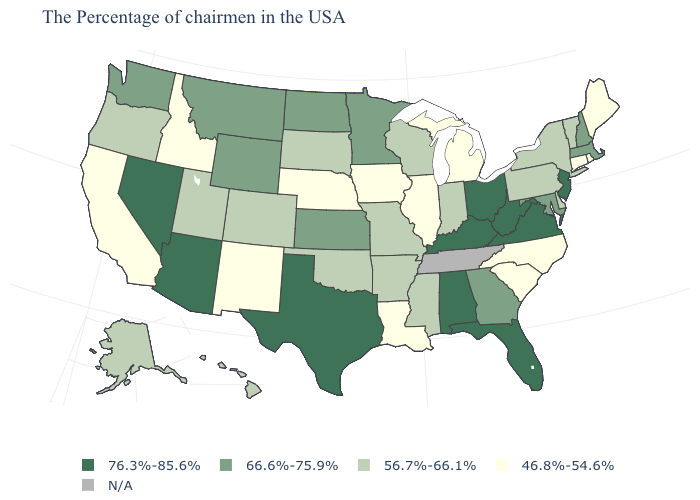What is the value of Virginia?
Quick response, please. 76.3%-85.6%. Name the states that have a value in the range 66.6%-75.9%?
Give a very brief answer. Massachusetts, New Hampshire, Maryland, Georgia, Minnesota, Kansas, North Dakota, Wyoming, Montana, Washington. Among the states that border Massachusetts , which have the highest value?
Short answer required. New Hampshire. Which states have the lowest value in the MidWest?
Concise answer only. Michigan, Illinois, Iowa, Nebraska. Among the states that border Wyoming , which have the highest value?
Quick response, please. Montana. What is the lowest value in the USA?
Keep it brief. 46.8%-54.6%. Name the states that have a value in the range N/A?
Write a very short answer. Tennessee. Among the states that border Georgia , does South Carolina have the lowest value?
Quick response, please. Yes. Which states have the highest value in the USA?
Write a very short answer. New Jersey, Virginia, West Virginia, Ohio, Florida, Kentucky, Alabama, Texas, Arizona, Nevada. Name the states that have a value in the range 56.7%-66.1%?
Write a very short answer. Vermont, New York, Delaware, Pennsylvania, Indiana, Wisconsin, Mississippi, Missouri, Arkansas, Oklahoma, South Dakota, Colorado, Utah, Oregon, Alaska, Hawaii. What is the highest value in the Northeast ?
Answer briefly. 76.3%-85.6%. What is the value of South Dakota?
Be succinct. 56.7%-66.1%. What is the value of New Hampshire?
Give a very brief answer. 66.6%-75.9%. Does Alabama have the highest value in the USA?
Keep it brief. Yes. 